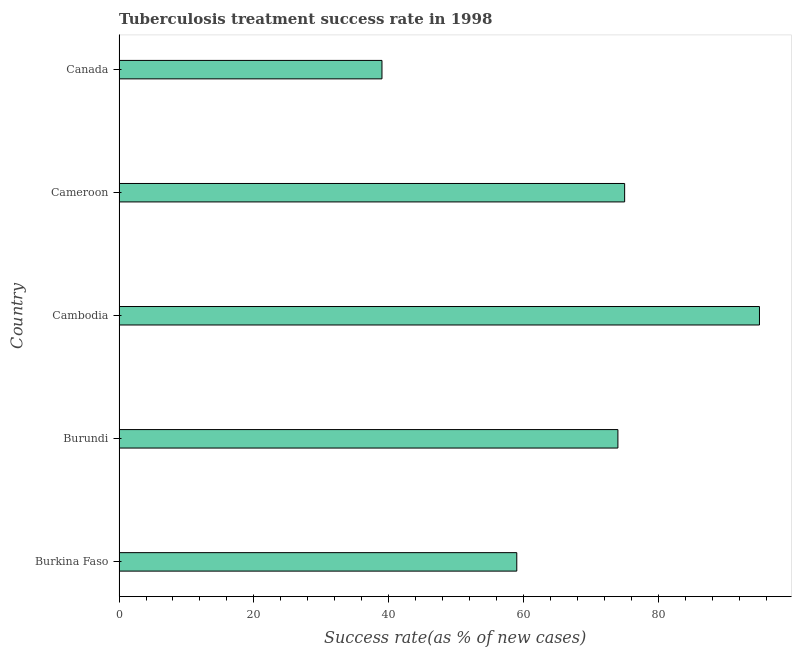What is the title of the graph?
Offer a very short reply. Tuberculosis treatment success rate in 1998. What is the label or title of the X-axis?
Make the answer very short. Success rate(as % of new cases). What is the label or title of the Y-axis?
Your answer should be very brief. Country. Across all countries, what is the minimum tuberculosis treatment success rate?
Keep it short and to the point. 39. In which country was the tuberculosis treatment success rate maximum?
Offer a terse response. Cambodia. What is the sum of the tuberculosis treatment success rate?
Your answer should be compact. 342. What is the average tuberculosis treatment success rate per country?
Your answer should be compact. 68. What is the median tuberculosis treatment success rate?
Keep it short and to the point. 74. In how many countries, is the tuberculosis treatment success rate greater than 44 %?
Make the answer very short. 4. What is the ratio of the tuberculosis treatment success rate in Burundi to that in Canada?
Make the answer very short. 1.9. Is the tuberculosis treatment success rate in Burundi less than that in Canada?
Your answer should be very brief. No. Is the difference between the tuberculosis treatment success rate in Burundi and Canada greater than the difference between any two countries?
Provide a succinct answer. No. What is the difference between the highest and the lowest tuberculosis treatment success rate?
Your response must be concise. 56. What is the difference between two consecutive major ticks on the X-axis?
Offer a terse response. 20. Are the values on the major ticks of X-axis written in scientific E-notation?
Keep it short and to the point. No. What is the Success rate(as % of new cases) of Burkina Faso?
Provide a short and direct response. 59. What is the Success rate(as % of new cases) of Burundi?
Keep it short and to the point. 74. What is the Success rate(as % of new cases) of Cambodia?
Your answer should be very brief. 95. What is the difference between the Success rate(as % of new cases) in Burkina Faso and Cambodia?
Your answer should be compact. -36. What is the difference between the Success rate(as % of new cases) in Burundi and Cambodia?
Your response must be concise. -21. What is the difference between the Success rate(as % of new cases) in Burundi and Canada?
Your response must be concise. 35. What is the difference between the Success rate(as % of new cases) in Cambodia and Canada?
Make the answer very short. 56. What is the difference between the Success rate(as % of new cases) in Cameroon and Canada?
Keep it short and to the point. 36. What is the ratio of the Success rate(as % of new cases) in Burkina Faso to that in Burundi?
Make the answer very short. 0.8. What is the ratio of the Success rate(as % of new cases) in Burkina Faso to that in Cambodia?
Your response must be concise. 0.62. What is the ratio of the Success rate(as % of new cases) in Burkina Faso to that in Cameroon?
Provide a succinct answer. 0.79. What is the ratio of the Success rate(as % of new cases) in Burkina Faso to that in Canada?
Your answer should be very brief. 1.51. What is the ratio of the Success rate(as % of new cases) in Burundi to that in Cambodia?
Ensure brevity in your answer.  0.78. What is the ratio of the Success rate(as % of new cases) in Burundi to that in Cameroon?
Give a very brief answer. 0.99. What is the ratio of the Success rate(as % of new cases) in Burundi to that in Canada?
Your response must be concise. 1.9. What is the ratio of the Success rate(as % of new cases) in Cambodia to that in Cameroon?
Your answer should be compact. 1.27. What is the ratio of the Success rate(as % of new cases) in Cambodia to that in Canada?
Your answer should be very brief. 2.44. What is the ratio of the Success rate(as % of new cases) in Cameroon to that in Canada?
Provide a short and direct response. 1.92. 